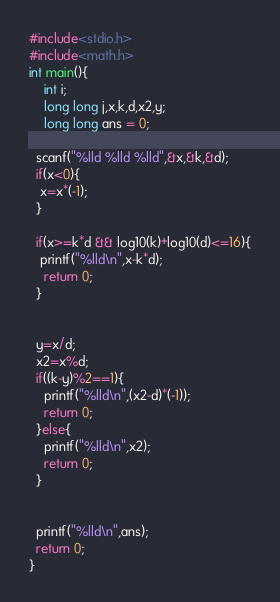Convert code to text. <code><loc_0><loc_0><loc_500><loc_500><_C_>#include<stdio.h>
#include<math.h>
int main(){
 	int i;	
  	long long j,x,k,d,x2,y;
  	long long ans = 0;
  
  scanf("%lld %lld %lld",&x,&k,&d);
  if(x<0){
   x=x*(-1); 
  }
  
  if(x>=k*d && log10(k)+log10(d)<=16){
   printf("%lld\n",x-k*d);
    return 0;
  }

  
  y=x/d;
  x2=x%d;
  if((k-y)%2==1){
    printf("%lld\n",(x2-d)*(-1));
    return 0;
  }else{
    printf("%lld\n",x2);
    return 0;
  }
  
  
  printf("%lld\n",ans);
  return 0;
}
</code> 